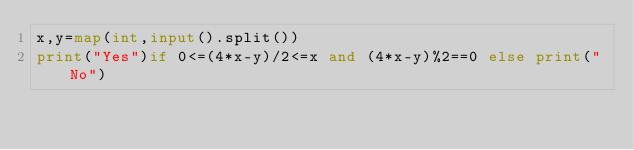<code> <loc_0><loc_0><loc_500><loc_500><_Python_>x,y=map(int,input().split())
print("Yes")if 0<=(4*x-y)/2<=x and (4*x-y)%2==0 else print("No")</code> 